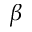Convert formula to latex. <formula><loc_0><loc_0><loc_500><loc_500>\beta</formula> 